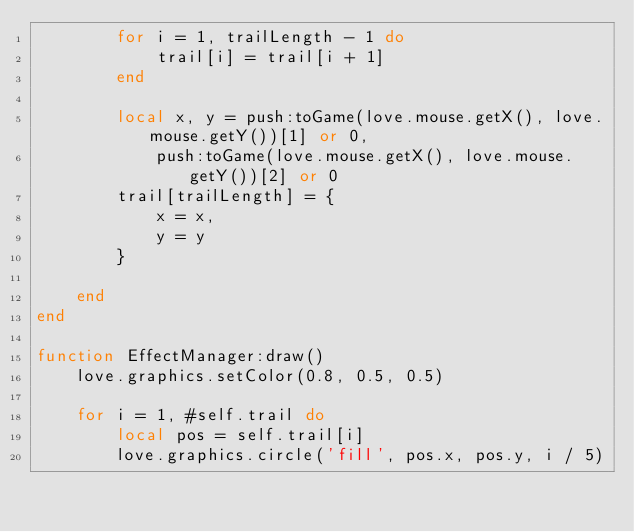Convert code to text. <code><loc_0><loc_0><loc_500><loc_500><_Lua_>        for i = 1, trailLength - 1 do
            trail[i] = trail[i + 1]
        end
		
        local x, y = push:toGame(love.mouse.getX(), love.mouse.getY())[1] or 0,
            push:toGame(love.mouse.getX(), love.mouse.getY())[2] or 0
        trail[trailLength] = {
            x = x,
            y = y
        }

    end
end

function EffectManager:draw()
    love.graphics.setColor(0.8, 0.5, 0.5)

    for i = 1, #self.trail do
        local pos = self.trail[i]
        love.graphics.circle('fill', pos.x, pos.y, i / 5)
</code> 